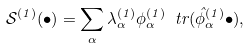Convert formula to latex. <formula><loc_0><loc_0><loc_500><loc_500>\mathcal { S } ^ { ( 1 ) } ( \bullet ) = \sum _ { \alpha } \lambda ^ { ( 1 ) } _ { \alpha } \phi ^ { ( 1 ) } _ { \alpha } \ t r ( \hat { \phi } ^ { ( 1 ) } _ { \alpha } \bullet ) ,</formula> 